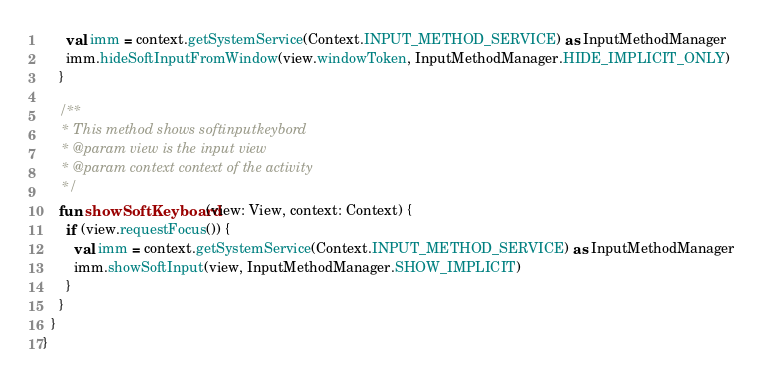Convert code to text. <code><loc_0><loc_0><loc_500><loc_500><_Kotlin_>      val imm = context.getSystemService(Context.INPUT_METHOD_SERVICE) as InputMethodManager
      imm.hideSoftInputFromWindow(view.windowToken, InputMethodManager.HIDE_IMPLICIT_ONLY)
    }

    /**
     * This method shows softinputkeybord
     * @param view is the input view
     * @param context context of the activity
     */
    fun showSoftKeyboard(view: View, context: Context) {
      if (view.requestFocus()) {
        val imm = context.getSystemService(Context.INPUT_METHOD_SERVICE) as InputMethodManager
        imm.showSoftInput(view, InputMethodManager.SHOW_IMPLICIT)
      }
    }
  }
}
</code> 